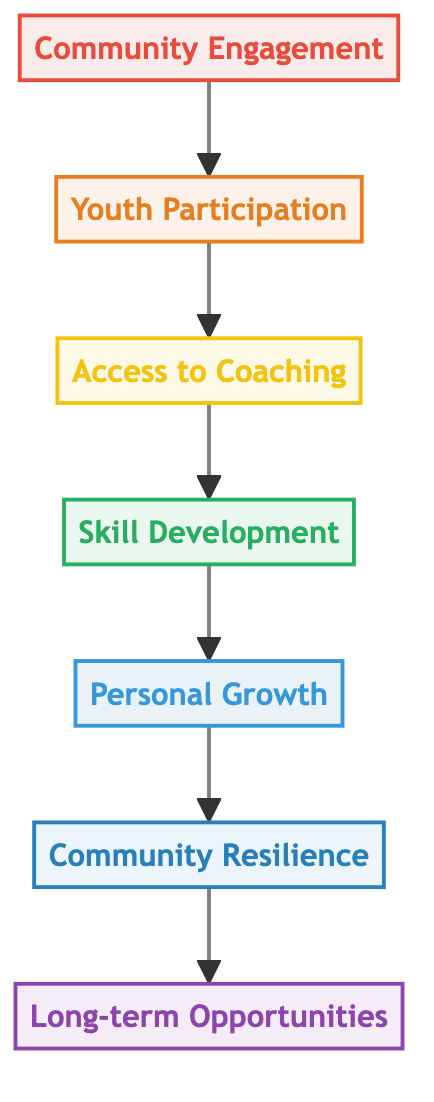What is the top node in the diagram? The top node in the diagram is "Long-term Opportunities," as it is the final outcome of the flow chart.
Answer: Long-term Opportunities How many levels are there in the diagram? The diagram contains seven levels, ranging from "Community Engagement" at the bottom to "Long-term Opportunities" at the top.
Answer: Seven What is the relationship between "Skill Development" and "Personal Growth"? "Skill Development" leads directly to "Personal Growth," indicating that skill development is a contributor to personal growth within the flow of the diagram.
Answer: Directly leads to What is the second node from the bottom? The second node from the bottom is "Youth Participation," which is the second level in the flow chart sequence before accessing coaching.
Answer: Youth Participation What does "Community Engagement" lead to? "Community Engagement" leads to "Youth Participation," which is the first step in the sequence illustrated by the flow chart.
Answer: Youth Participation What is the role of "Access to Coaching" in the diagram? "Access to Coaching" serves as the third node in the flow chart that facilitates skill development among the youth by providing training and mentorship.
Answer: Facilitates skill development If "Community Engagement" increases, what is the next expected outcome? An increase in "Community Engagement" is expected to increase "Youth Participation," as the flow indicates that greater community involvement leads to more youth participating in cricket activities.
Answer: Youth Participation What is the final outcome of the diagram? The final outcome of the diagram is "Long-term Opportunities," which reflects the ultimate benefits of the grassroots cricket program for youth.
Answer: Long-term Opportunities What factors contribute to "Community Resilience"? "Personal Growth" and "Skill Development" both contribute to "Community Resilience," as indicated in the diagram where these factors are prerequisites for developing a stronger community spirit.
Answer: Personal Growth and Skill Development 